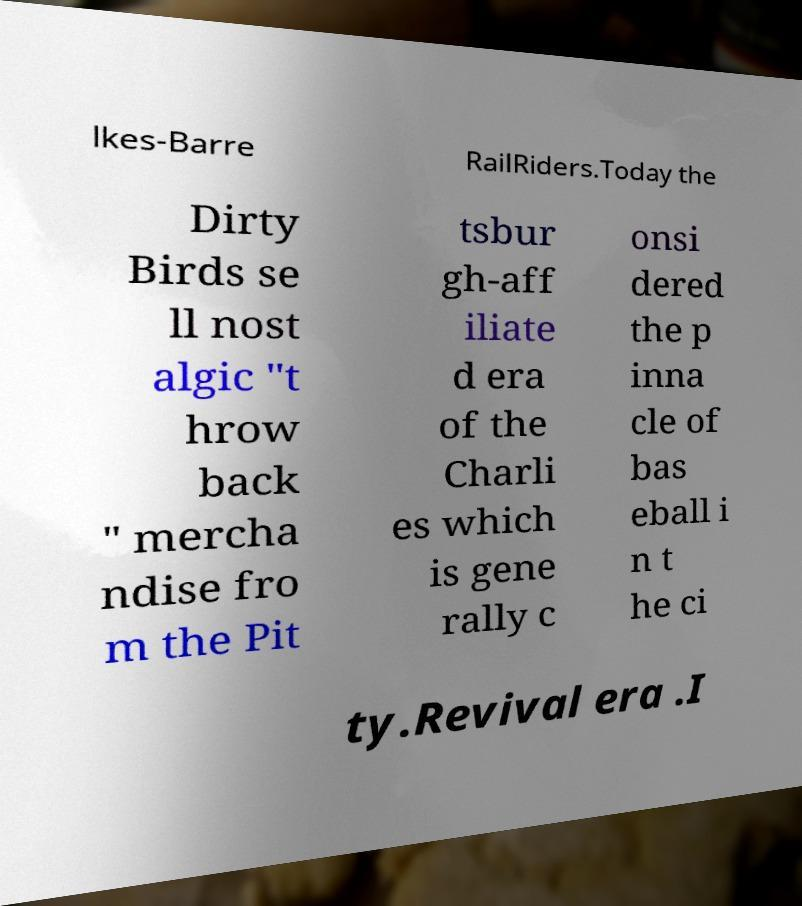Can you accurately transcribe the text from the provided image for me? lkes-Barre RailRiders.Today the Dirty Birds se ll nost algic "t hrow back " mercha ndise fro m the Pit tsbur gh-aff iliate d era of the Charli es which is gene rally c onsi dered the p inna cle of bas eball i n t he ci ty.Revival era .I 